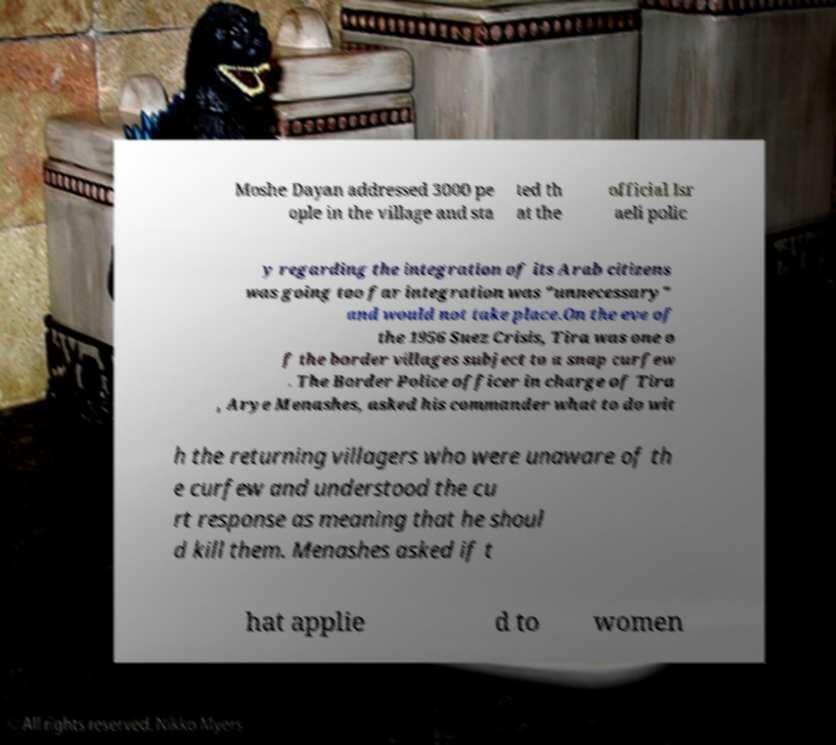Can you accurately transcribe the text from the provided image for me? Moshe Dayan addressed 3000 pe ople in the village and sta ted th at the official Isr aeli polic y regarding the integration of its Arab citizens was going too far integration was "unnecessary" and would not take place.On the eve of the 1956 Suez Crisis, Tira was one o f the border villages subject to a snap curfew . The Border Police officer in charge of Tira , Arye Menashes, asked his commander what to do wit h the returning villagers who were unaware of th e curfew and understood the cu rt response as meaning that he shoul d kill them. Menashes asked if t hat applie d to women 